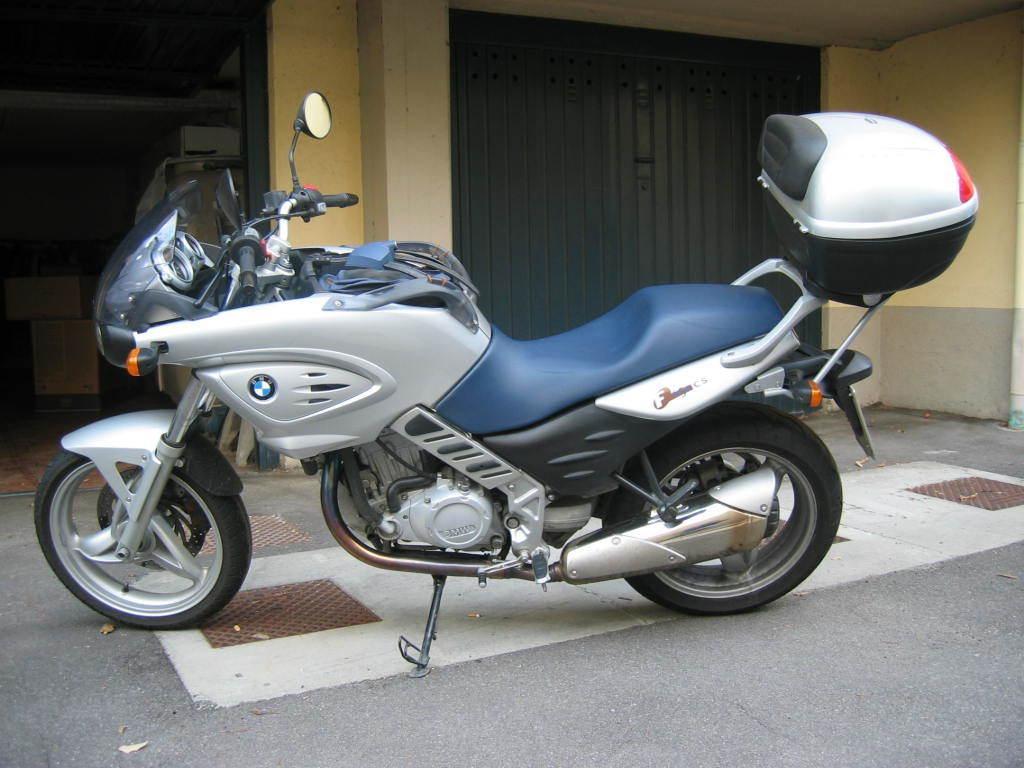Please provide a concise description of this image. In this image we can see a motorcycle placed on the ground. In the background we can see a door. 